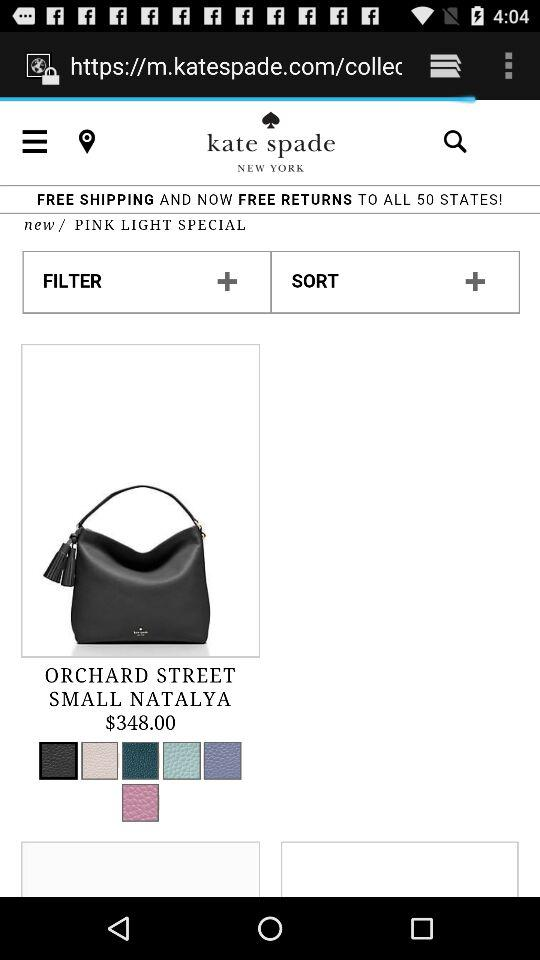How many states are listed for free shipping and free returns? There are 50 states listed for free shipping and free returns. 